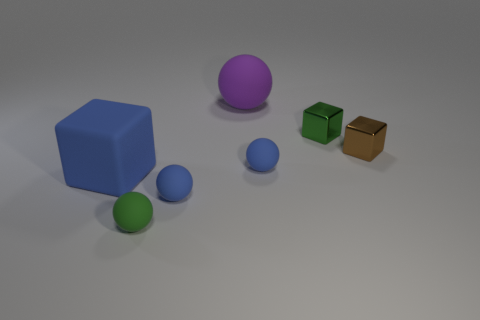The green shiny thing is what size?
Your answer should be compact. Small. There is a blue matte block; does it have the same size as the cube behind the small brown metallic block?
Provide a short and direct response. No. What is the color of the big thing on the right side of the cube that is on the left side of the purple object?
Offer a terse response. Purple. Are there an equal number of small blue objects that are to the left of the big sphere and purple balls right of the tiny green shiny thing?
Offer a terse response. No. Is the tiny green thing that is in front of the tiny brown metallic thing made of the same material as the tiny brown thing?
Your response must be concise. No. What is the color of the thing that is both behind the tiny brown block and in front of the large sphere?
Provide a short and direct response. Green. There is a small green thing that is in front of the tiny brown metallic object; what number of small rubber objects are to the left of it?
Give a very brief answer. 0. There is a tiny brown object that is the same shape as the big blue matte object; what is its material?
Give a very brief answer. Metal. What is the color of the matte cube?
Your answer should be compact. Blue. What number of things are big spheres or large brown cylinders?
Keep it short and to the point. 1. 